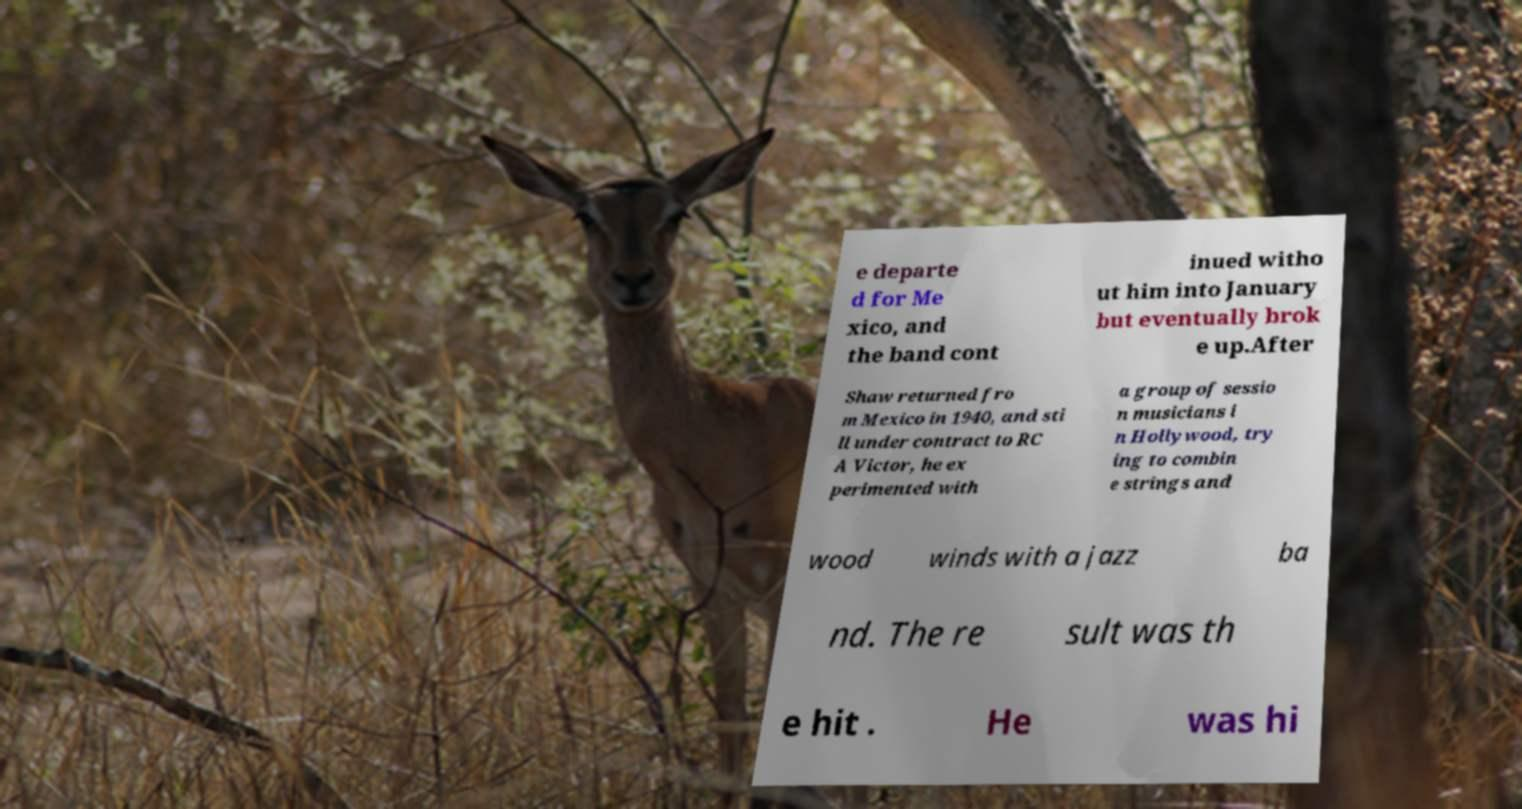Could you extract and type out the text from this image? e departe d for Me xico, and the band cont inued witho ut him into January but eventually brok e up.After Shaw returned fro m Mexico in 1940, and sti ll under contract to RC A Victor, he ex perimented with a group of sessio n musicians i n Hollywood, try ing to combin e strings and wood winds with a jazz ba nd. The re sult was th e hit . He was hi 